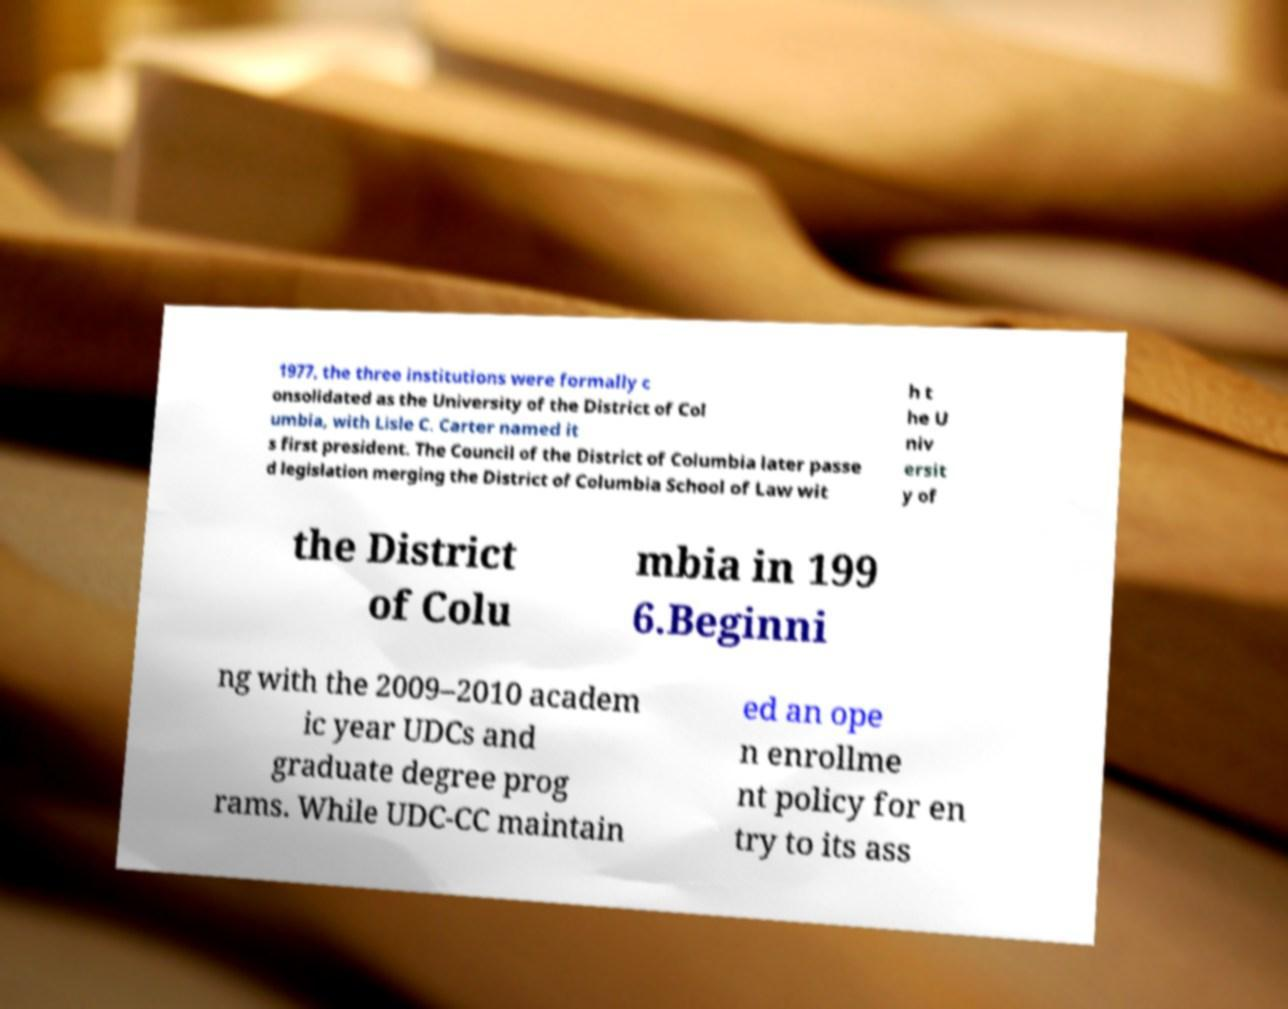Could you assist in decoding the text presented in this image and type it out clearly? 1977, the three institutions were formally c onsolidated as the University of the District of Col umbia, with Lisle C. Carter named it s first president. The Council of the District of Columbia later passe d legislation merging the District of Columbia School of Law wit h t he U niv ersit y of the District of Colu mbia in 199 6.Beginni ng with the 2009–2010 academ ic year UDCs and graduate degree prog rams. While UDC-CC maintain ed an ope n enrollme nt policy for en try to its ass 